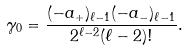<formula> <loc_0><loc_0><loc_500><loc_500>\gamma _ { 0 } = \frac { ( - a _ { + } ) _ { \ell - 1 } ( - a _ { - } ) _ { \ell - 1 } } { 2 ^ { \ell - 2 } ( \ell - 2 ) ! } .</formula> 